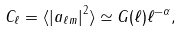Convert formula to latex. <formula><loc_0><loc_0><loc_500><loc_500>C _ { \ell } = \langle \left | a _ { \ell m } \right | ^ { 2 } \rangle \simeq G ( \ell ) \ell ^ { - \alpha } ,</formula> 